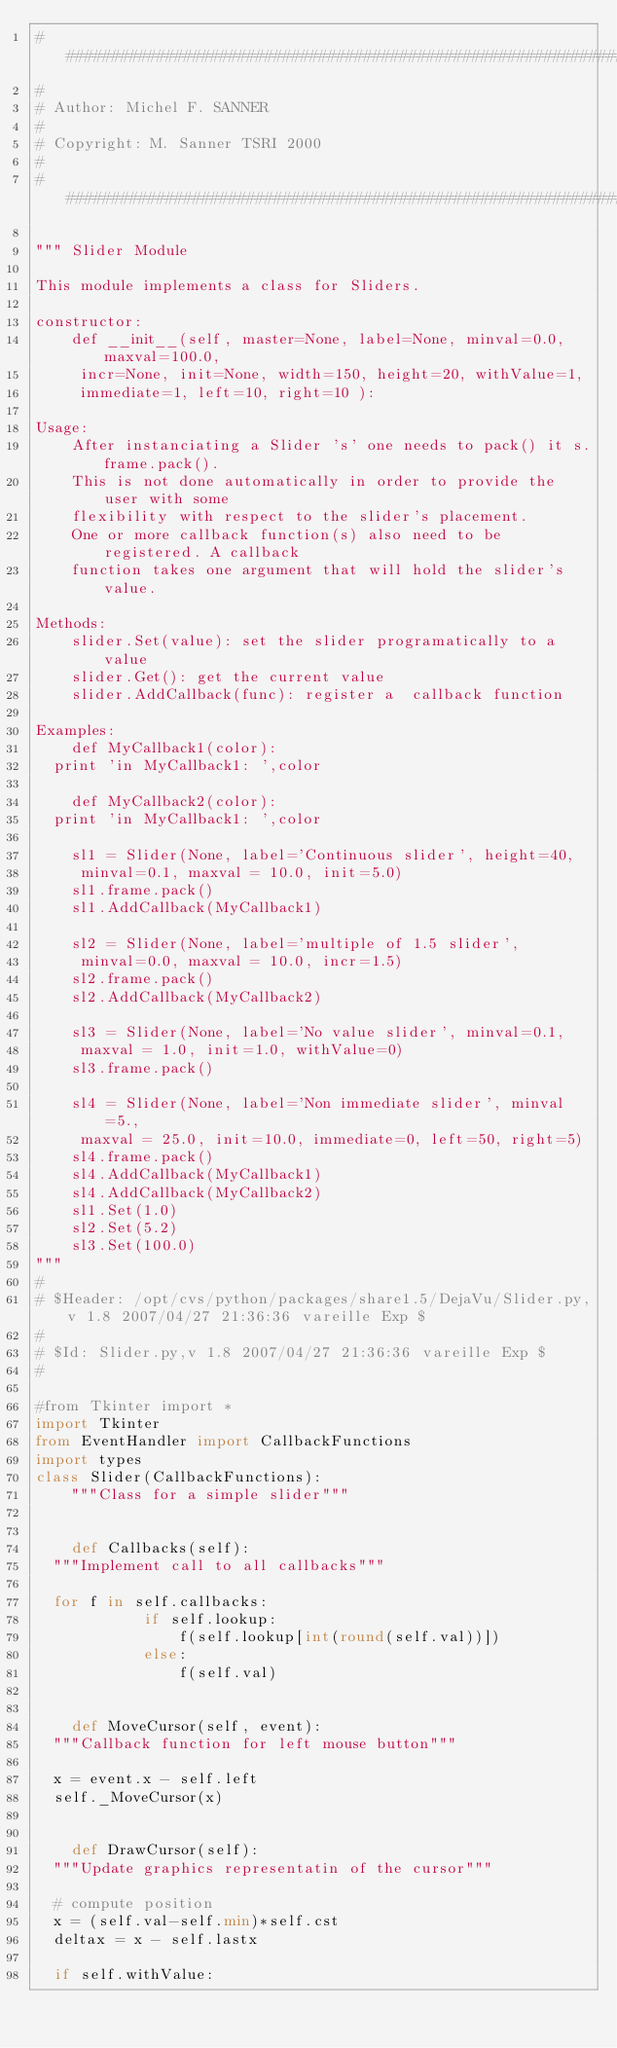<code> <loc_0><loc_0><loc_500><loc_500><_Python_>#############################################################################
#
# Author: Michel F. SANNER
#
# Copyright: M. Sanner TSRI 2000
#
#############################################################################

""" Slider Module

This module implements a class for Sliders.

constructor:
    def __init__(self, master=None, label=None, minval=0.0, maxval=100.0,
		 incr=None, init=None, width=150, height=20, withValue=1,
		 immediate=1, left=10, right=10 ):

Usage:
    After instanciating a Slider 's' one needs to pack() it s.frame.pack().
    This is not done automatically in order to provide the user with some
    flexibility with respect to the slider's placement.
    One or more callback function(s) also need to be registered. A callback
    function takes one argument that will hold the slider's value.

Methods:
    slider.Set(value): set the slider programatically to a value
    slider.Get(): get the current value
    slider.AddCallback(func): register a  callback function
    
Examples:
    def MyCallback1(color):
	print 'in MyCallback1: ',color

    def MyCallback2(color):
	print 'in MyCallback1: ',color

    sl1 = Slider(None, label='Continuous slider', height=40,
		 minval=0.1, maxval = 10.0, init=5.0)
    sl1.frame.pack()
    sl1.AddCallback(MyCallback1)

    sl2 = Slider(None, label='multiple of 1.5 slider',
		 minval=0.0, maxval = 10.0, incr=1.5)
    sl2.frame.pack()
    sl2.AddCallback(MyCallback2)

    sl3 = Slider(None, label='No value slider', minval=0.1,
		 maxval = 1.0, init=1.0, withValue=0)
    sl3.frame.pack()

    sl4 = Slider(None, label='Non immediate slider', minval=5.,
		 maxval = 25.0, init=10.0, immediate=0, left=50, right=5)
    sl4.frame.pack()
    sl4.AddCallback(MyCallback1)
    sl4.AddCallback(MyCallback2)
    sl1.Set(1.0)
    sl2.Set(5.2)
    sl3.Set(100.0)
"""
#
# $Header: /opt/cvs/python/packages/share1.5/DejaVu/Slider.py,v 1.8 2007/04/27 21:36:36 vareille Exp $
#
# $Id: Slider.py,v 1.8 2007/04/27 21:36:36 vareille Exp $
#

#from Tkinter import *
import Tkinter
from EventHandler import CallbackFunctions
import types
class Slider(CallbackFunctions):
    """Class for a simple slider"""


    def Callbacks(self):
	"""Implement call to all callbacks"""

	for f in self.callbacks:
            if self.lookup:
                f(self.lookup[int(round(self.val))])
            else:
                f(self.val)


    def MoveCursor(self, event):
	"""Callback function for left mouse button"""

	x = event.x - self.left
	self._MoveCursor(x)


    def DrawCursor(self):
	"""Update graphics representatin of the cursor"""

	# compute position
	x = (self.val-self.min)*self.cst
	deltax = x - self.lastx

	if self.withValue:</code> 